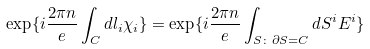Convert formula to latex. <formula><loc_0><loc_0><loc_500><loc_500>\exp \{ i \frac { 2 \pi n } { e } \int _ { C } d l _ { i } \chi _ { i } \} = \exp \{ i \frac { 2 \pi n } { e } \int _ { S \colon \partial S = C } d S ^ { i } E ^ { i } \}</formula> 